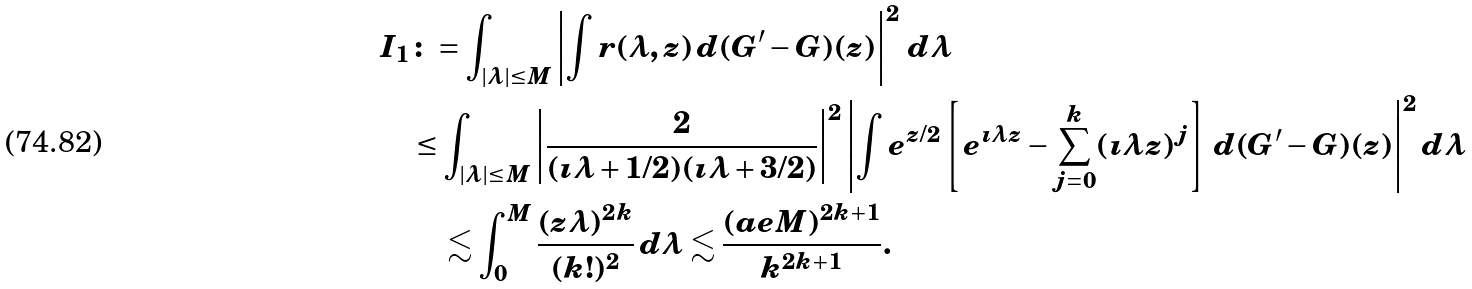Convert formula to latex. <formula><loc_0><loc_0><loc_500><loc_500>I _ { 1 } & \colon = \int _ { | \lambda | \leq M } \left | \int r ( \lambda , z ) \, d ( { G ^ { \prime } } - G ) ( z ) \right | ^ { 2 } \, d \lambda \\ & \leq \int _ { | \lambda | \leq M } \left | \frac { 2 } { ( \imath \lambda + 1 / 2 ) ( \imath \lambda + 3 / 2 ) } \right | ^ { 2 } \left | \int e ^ { z / 2 } \left [ e ^ { \imath \lambda z } - \sum _ { j = 0 } ^ { k } ( \imath \lambda z ) ^ { j } \right ] \, d ( { G ^ { \prime } } - G ) ( z ) \right | ^ { 2 } d \lambda \\ & \quad \lesssim \int _ { 0 } ^ { M } \frac { ( z \lambda ) ^ { 2 k } } { ( k ! ) ^ { 2 } } \, d \lambda \lesssim \frac { ( a e M ) ^ { 2 k + 1 } } { k ^ { 2 k + 1 } } .</formula> 